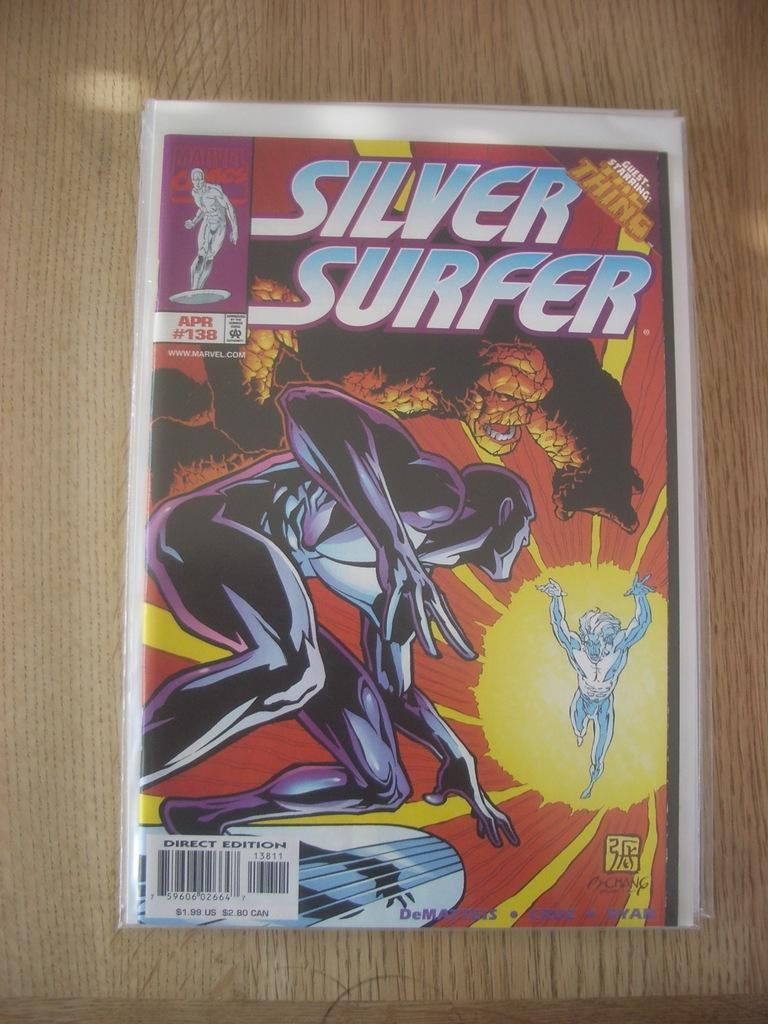<image>
Provide a brief description of the given image. A comic book that is called Silver Surfer. 